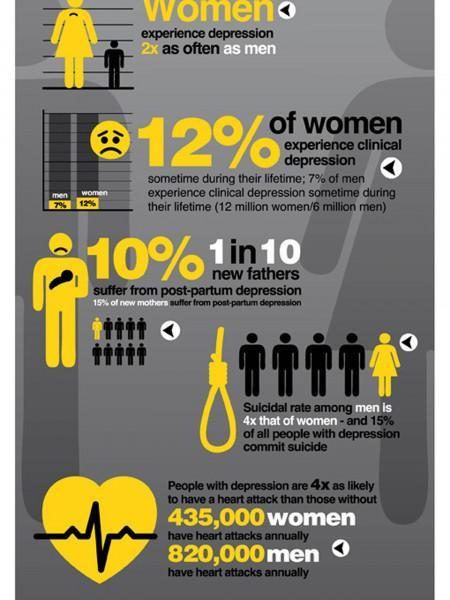How many women out of 5 people tend have a suicidal tendency, 1, 4, or 5?
Answer the question with a short phrase. 1 